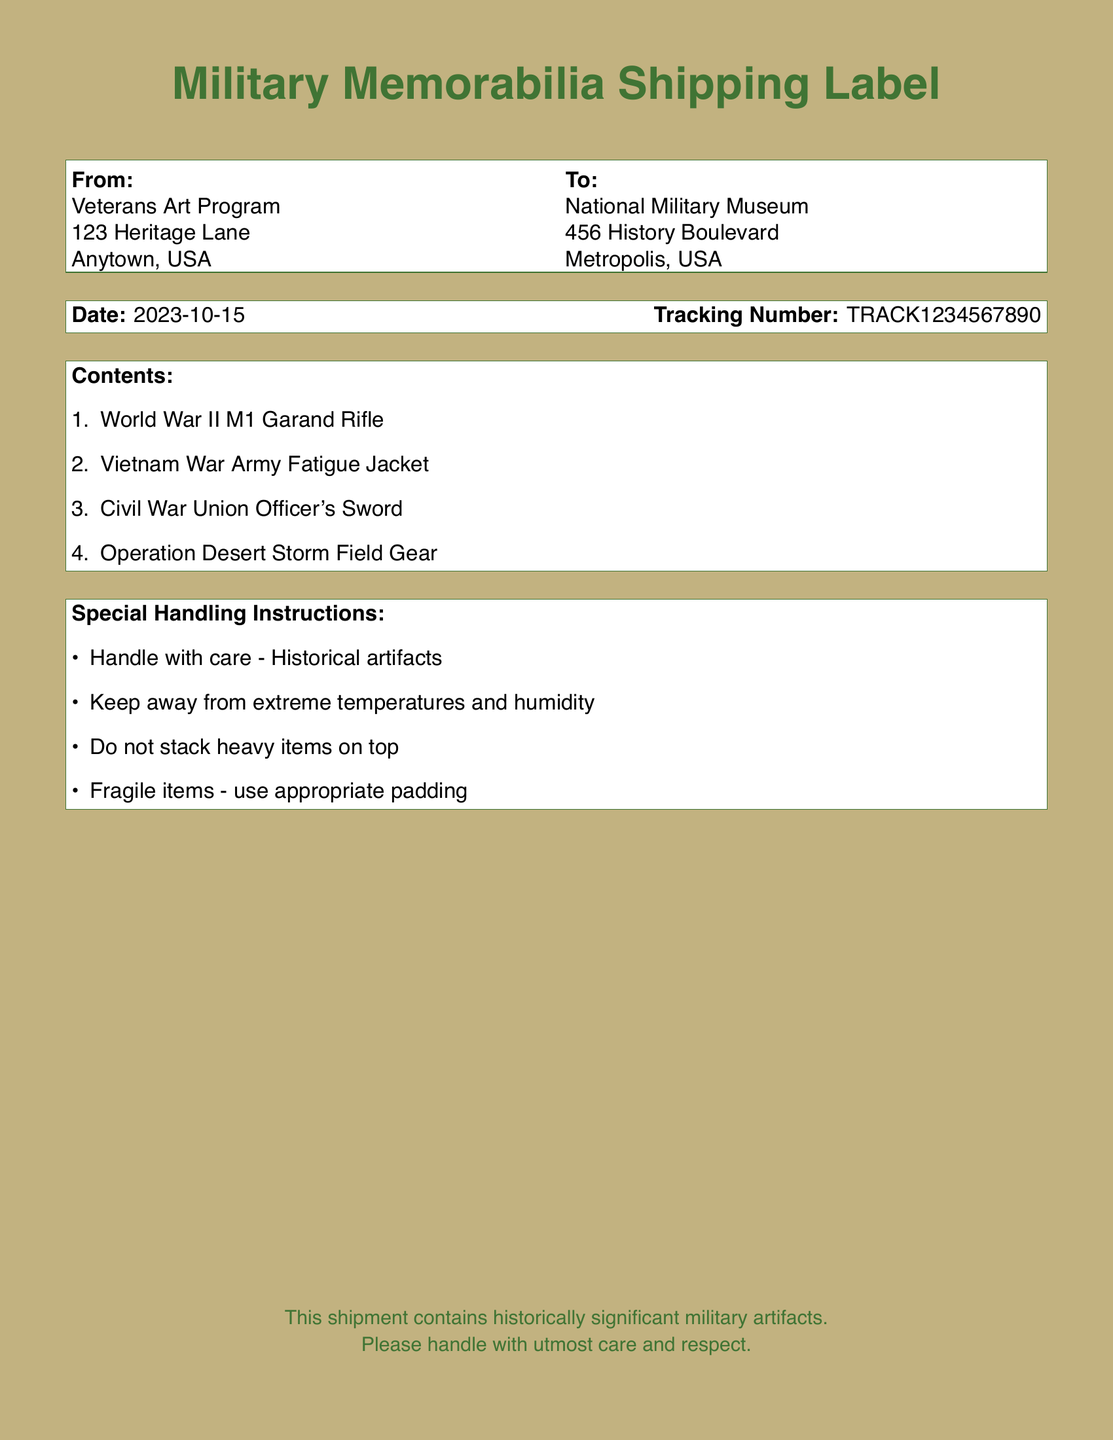What is the date of shipment? The date of shipment is explicitly mentioned in the document.
Answer: 2023-10-15 Who is the sender of the shipment? The sender's name can be found in the "From" section of the document.
Answer: Veterans Art Program What is the tracking number? The tracking number is provided in the designated section of the shipping label.
Answer: TRACK1234567890 What is the first item listed in the contents? This information can be found in the "Contents" list in the document.
Answer: World War II M1 Garand Rifle What special handling instruction emphasizes care? The document contains multiple instructions; this one is common for fragile items.
Answer: Handle with care - Historical artifacts How many items are listed in the contents? The number of items is indicated by the enumeration in the "Contents" section.
Answer: 4 What is the type of the second item sent? The contents list specifies the type of each item included in the shipment.
Answer: Army Fatigue Jacket What is the recipient's address? The recipient's address is included in the "To" section of the document.
Answer: 456 History Boulevard, Metropolis, USA What artifact is related to the Vietnam War? The question refers to the specific context of one of the listed items in the document.
Answer: Army Fatigue Jacket 